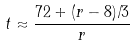Convert formula to latex. <formula><loc_0><loc_0><loc_500><loc_500>t \approx \frac { 7 2 + ( r - 8 ) / 3 } { r }</formula> 